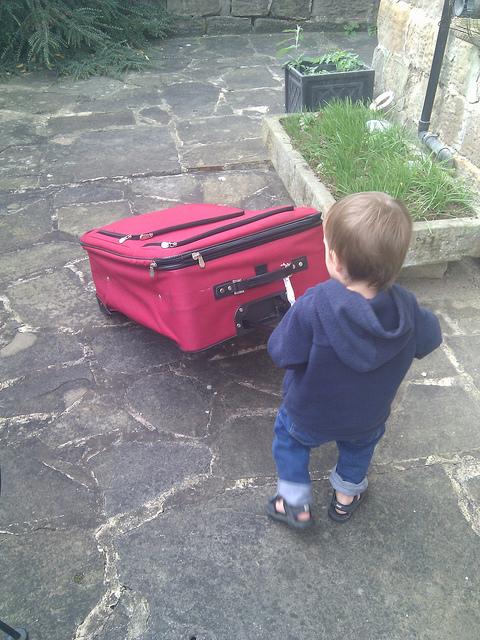What color is the suitcase?
Concise answer only. Red. What is the baby pulling?
Give a very brief answer. Suitcase. What type of footwear is the baby wearing?
Concise answer only. Sandals. 